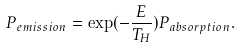<formula> <loc_0><loc_0><loc_500><loc_500>P _ { e m i s s i o n } = \exp ( - \frac { E } { T _ { H } } ) P _ { a b s o r p t i o n } .</formula> 